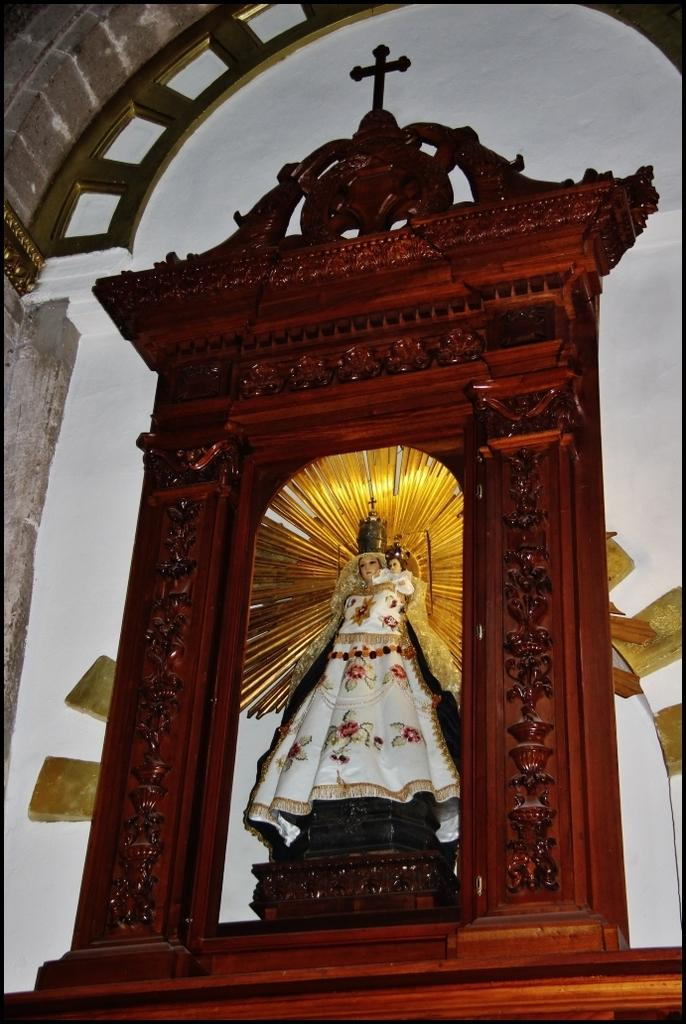What type of building is depicted in the image? The image shows the inside of a church. What can be seen on the wall in the image? There is a wooden construction on the wall. What is placed on the wooden structure? A woman statue is present on the wooden structure. What religious symbol is also on the wooden structure? There is a cross on the wooden structure. What type of bead is used to decorate the hospital in the image? There is no hospital or bead present in the image; it shows the inside of a church with a wooden structure featuring a woman statue and a cross. 